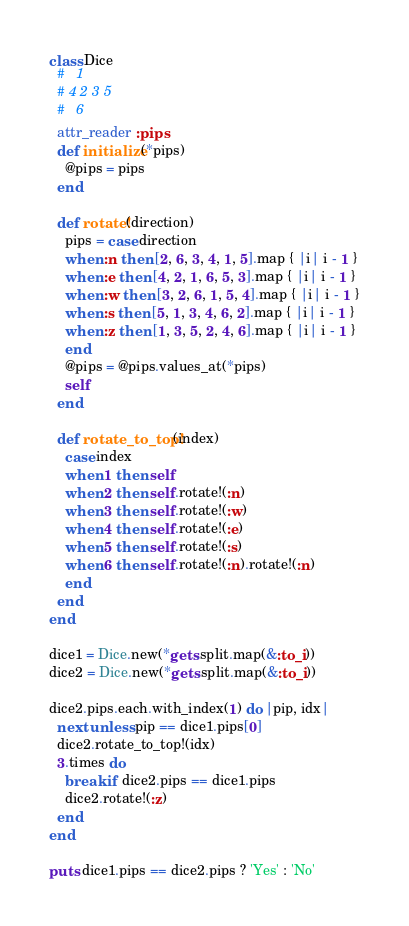Convert code to text. <code><loc_0><loc_0><loc_500><loc_500><_Ruby_>class Dice
  #   1
  # 4 2 3 5
  #   6
  attr_reader :pips
  def initialize(*pips)
    @pips = pips
  end

  def rotate!(direction)
    pips = case direction
    when :n then [2, 6, 3, 4, 1, 5].map { |i| i - 1 }
    when :e then [4, 2, 1, 6, 5, 3].map { |i| i - 1 }
    when :w then [3, 2, 6, 1, 5, 4].map { |i| i - 1 }
    when :s then [5, 1, 3, 4, 6, 2].map { |i| i - 1 }
    when :z then [1, 3, 5, 2, 4, 6].map { |i| i - 1 }
    end
    @pips = @pips.values_at(*pips)
    self
  end

  def rotate_to_top!(index)
    case index
    when 1 then self
    when 2 then self.rotate!(:n)
    when 3 then self.rotate!(:w)
    when 4 then self.rotate!(:e)
    when 5 then self.rotate!(:s)
    when 6 then self.rotate!(:n).rotate!(:n)
    end
  end
end

dice1 = Dice.new(*gets.split.map(&:to_i))
dice2 = Dice.new(*gets.split.map(&:to_i))

dice2.pips.each.with_index(1) do |pip, idx|
  next unless pip == dice1.pips[0]
  dice2.rotate_to_top!(idx)
  3.times do
    break if dice2.pips == dice1.pips
    dice2.rotate!(:z)
  end
end

puts dice1.pips == dice2.pips ? 'Yes' : 'No'</code> 